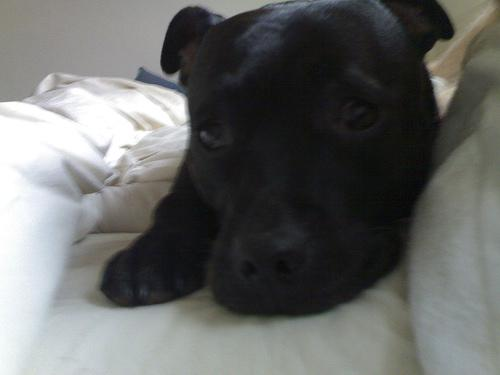Question: how many eyes does the dog have?
Choices:
A. One.
B. Zero.
C. Three.
D. Two.
Answer with the letter. Answer: D Question: what is the dog on?
Choices:
A. Dog bed.
B. Towels.
C. Blankets.
D. Pillows.
Answer with the letter. Answer: C 